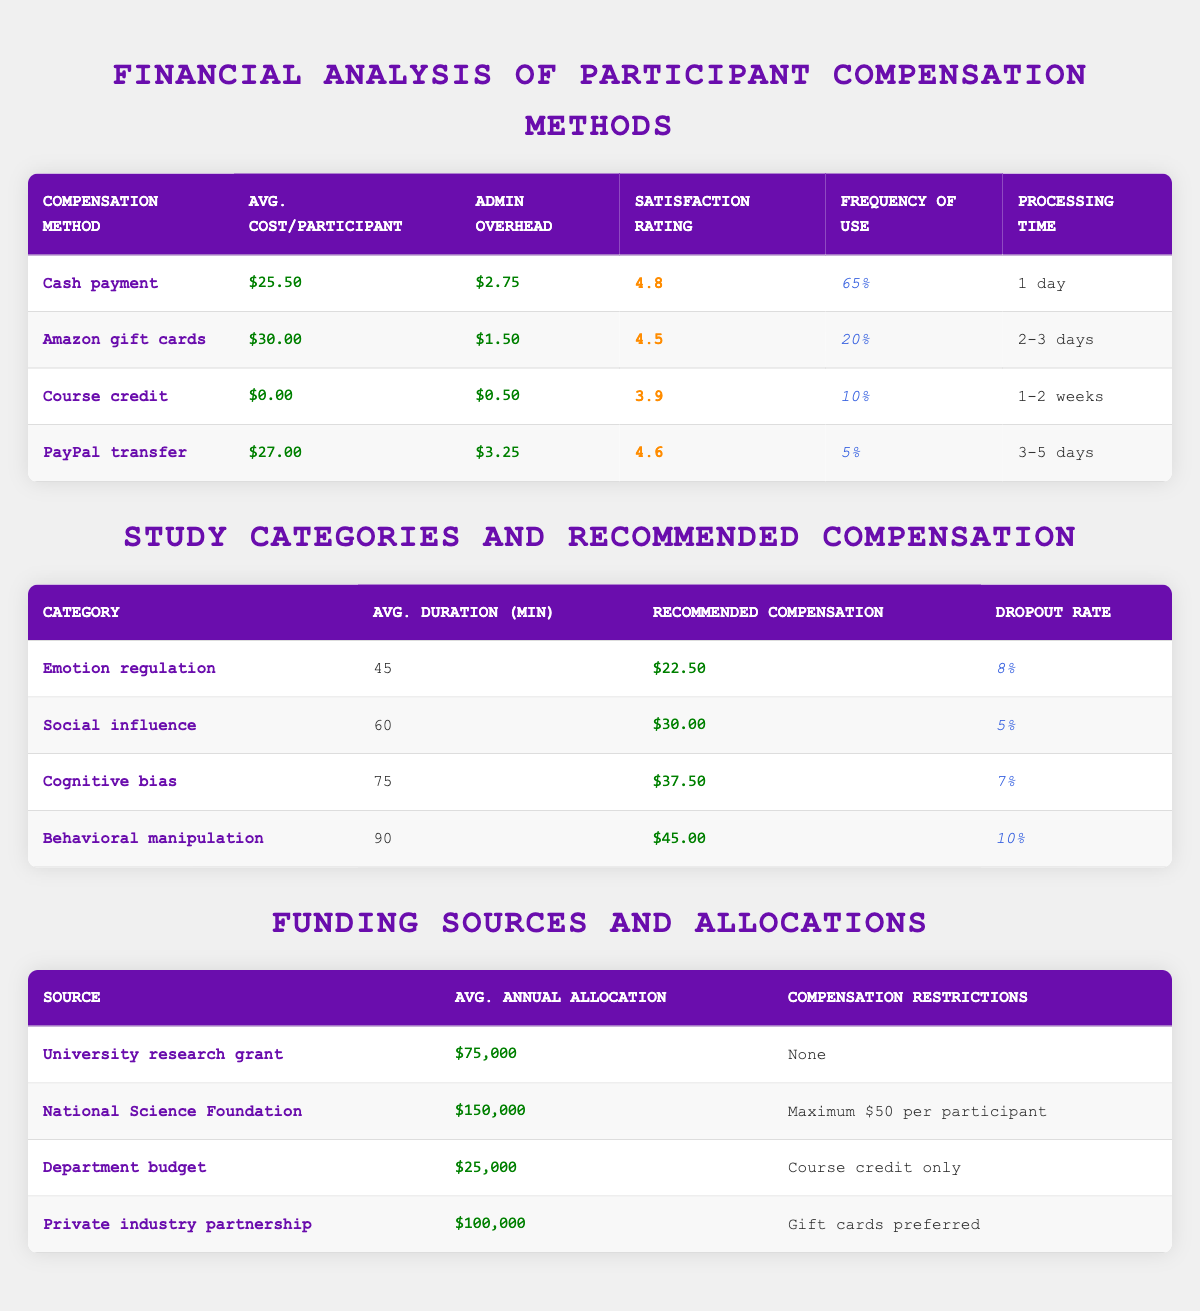What is the average satisfaction rating for cash payments? The satisfaction rating for cash payments is given in the table as 4.8, meaning it is the highest rating among the listed compensation methods.
Answer: 4.8 What is the total average cost per participant for the three highest compensation methods? The highest average costs per participant are for Amazon gift cards ($30.00), PayPal transfer ($27.00), and cash payment ($25.50). Adding these gives us 30 + 27 + 25.50 = 82.50.
Answer: 82.50 Is the participant dropout rate for social influence studies higher than that for emotional regulation studies? The dropout rate for social influence is 5%, while for emotion regulation it is 8%. Since 5% is less than 8%, the statement is false.
Answer: No Which compensation method has the lowest administrative overhead? The compensation method with the lowest administrative overhead is Amazon gift cards with $1.50. By reviewing the data, cash payments ($2.75), PayPal transfers ($3.25), and course credit ($0.50) are higher.
Answer: $1.50 What is the average recommended compensation for cognitive bias and behavioral manipulation categories combined? The recommended compensation for cognitive bias is $37.50 and for behavioral manipulation it is $45.00. Adding these gives 37.50 + 45 = 82.50. To find the average, divide by 2: 82.50 / 2 = 41.25.
Answer: 41.25 Does the National Science Foundation impose any restrictions on participant compensation? According to the table, the National Science Foundation has a restriction of a maximum of $50 per participant, indicating that it does impose some limitations.
Answer: Yes What is the frequency of use for PayPal transfers compared to cash payments? The frequency of use for PayPal transfers is 5%, and for cash payments, it is 65%. Since 5% is significantly lower than 65%, the statement holds true.
Answer: Lower What is the average duration of social influence studies compared to cognitive bias studies? The average duration for social influence studies is 60 minutes, while for cognitive bias studies it is 75 minutes. By comparing these durations, cognitive bias studies take longer than social influence studies.
Answer: Cognitive bias studies are longer 